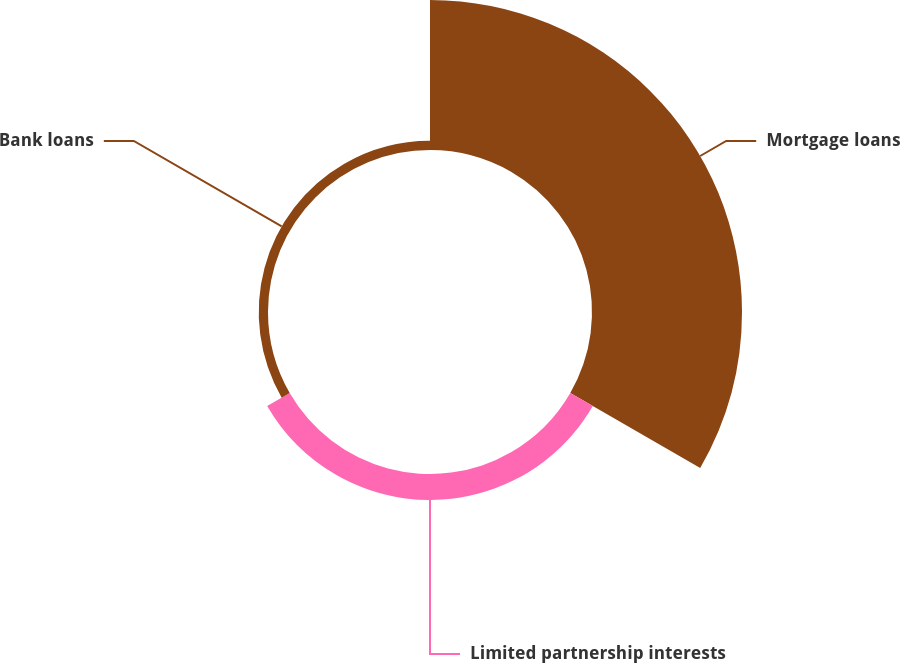Convert chart to OTSL. <chart><loc_0><loc_0><loc_500><loc_500><pie_chart><fcel>Mortgage loans<fcel>Limited partnership interests<fcel>Bank loans<nl><fcel>80.97%<fcel>14.03%<fcel>5.0%<nl></chart> 